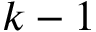Convert formula to latex. <formula><loc_0><loc_0><loc_500><loc_500>k - 1</formula> 